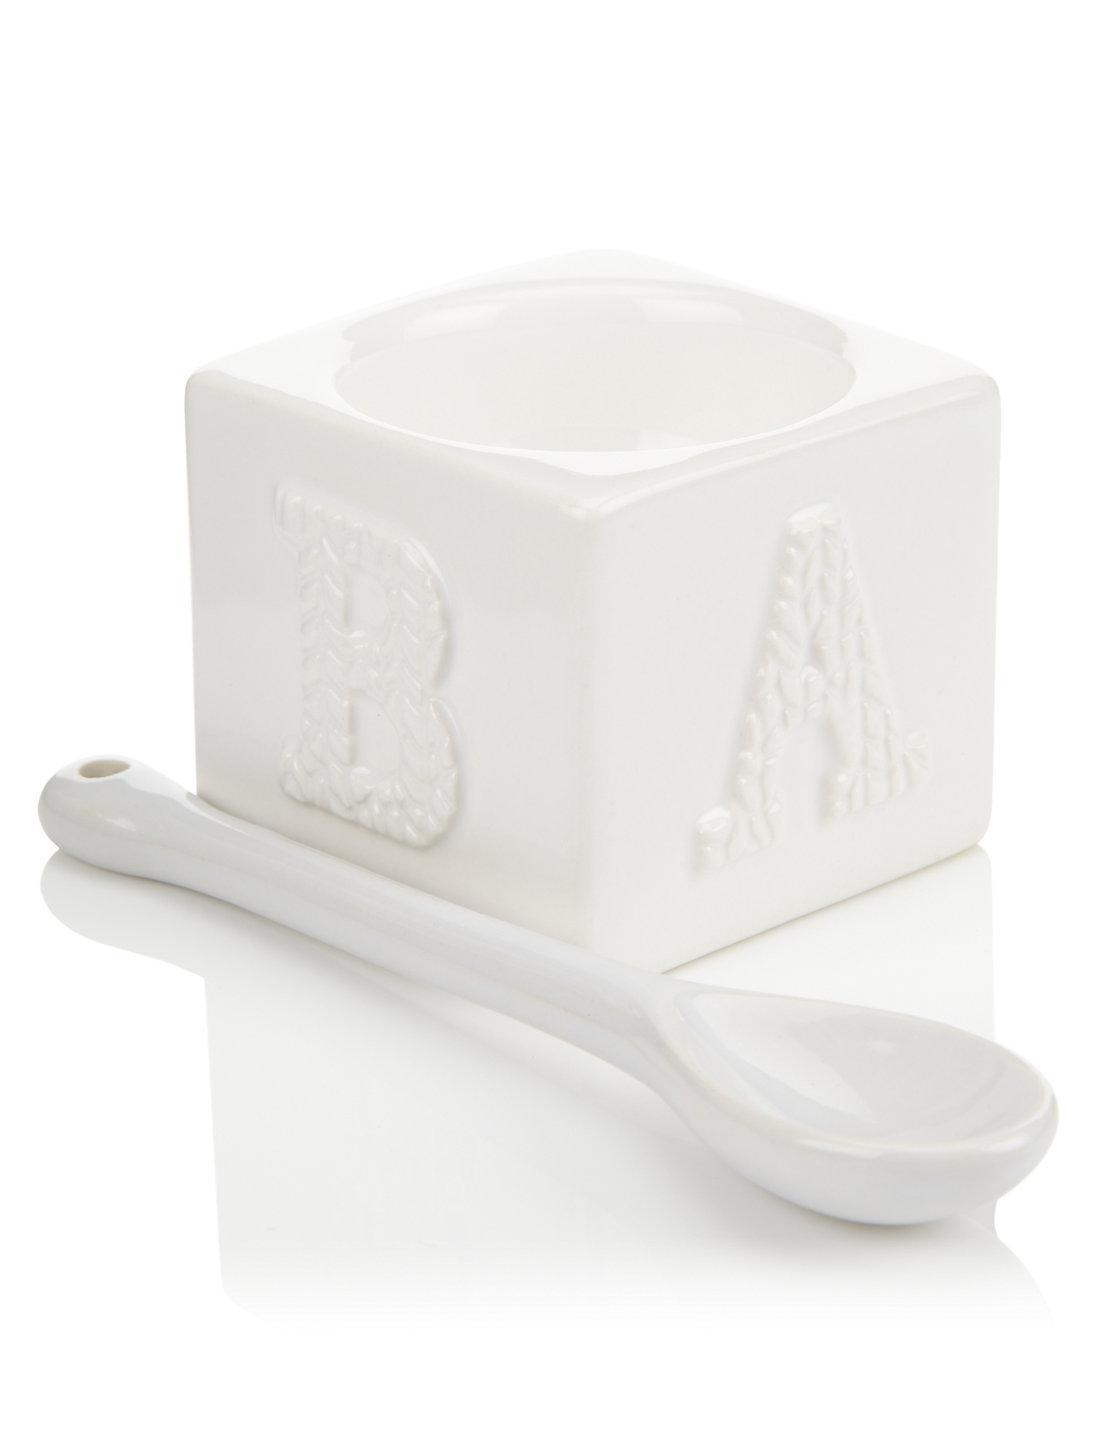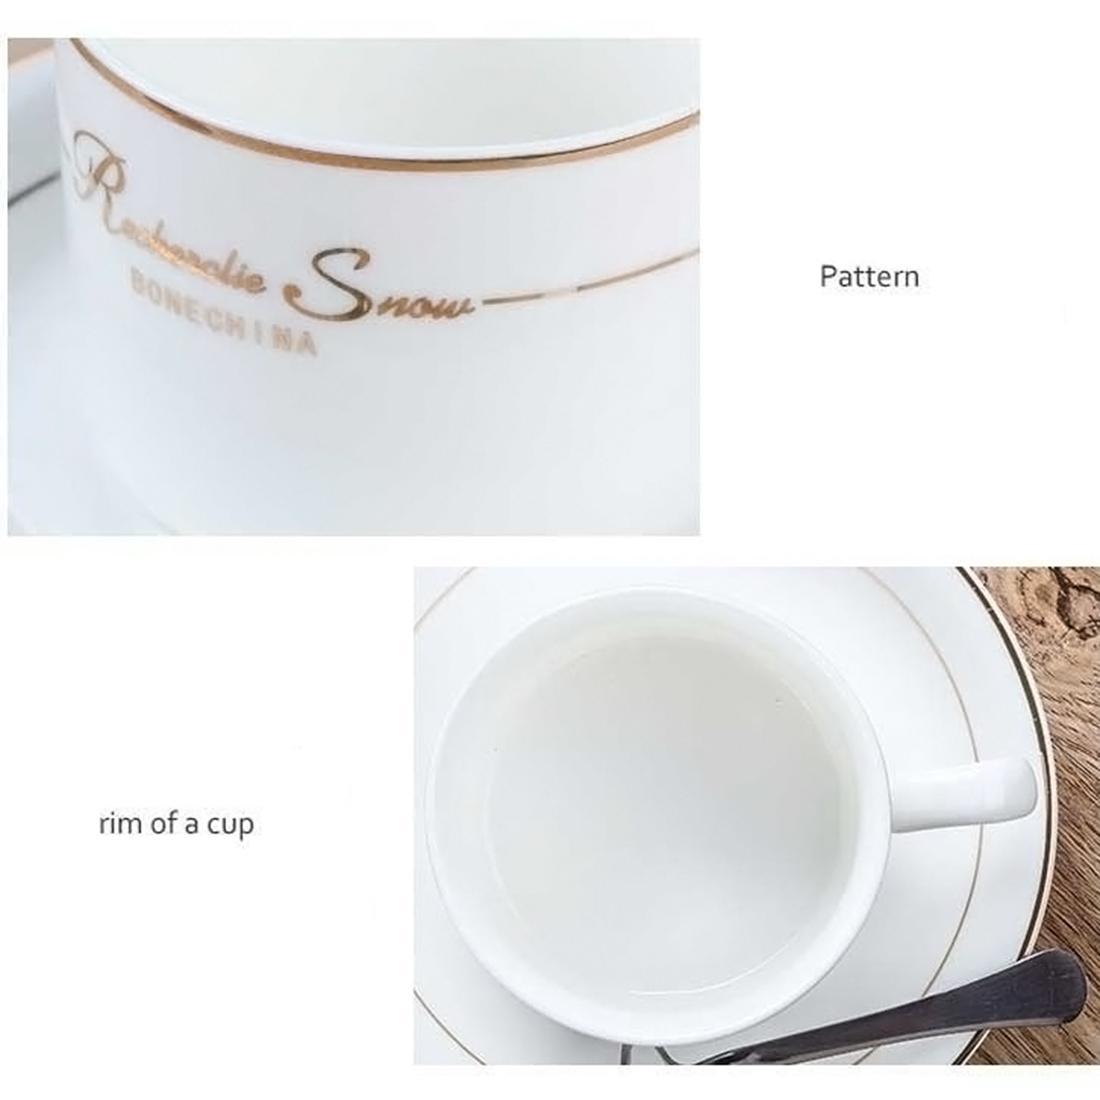The first image is the image on the left, the second image is the image on the right. Considering the images on both sides, is "The left image depicts exactly one spoon next to one container." valid? Answer yes or no. Yes. 